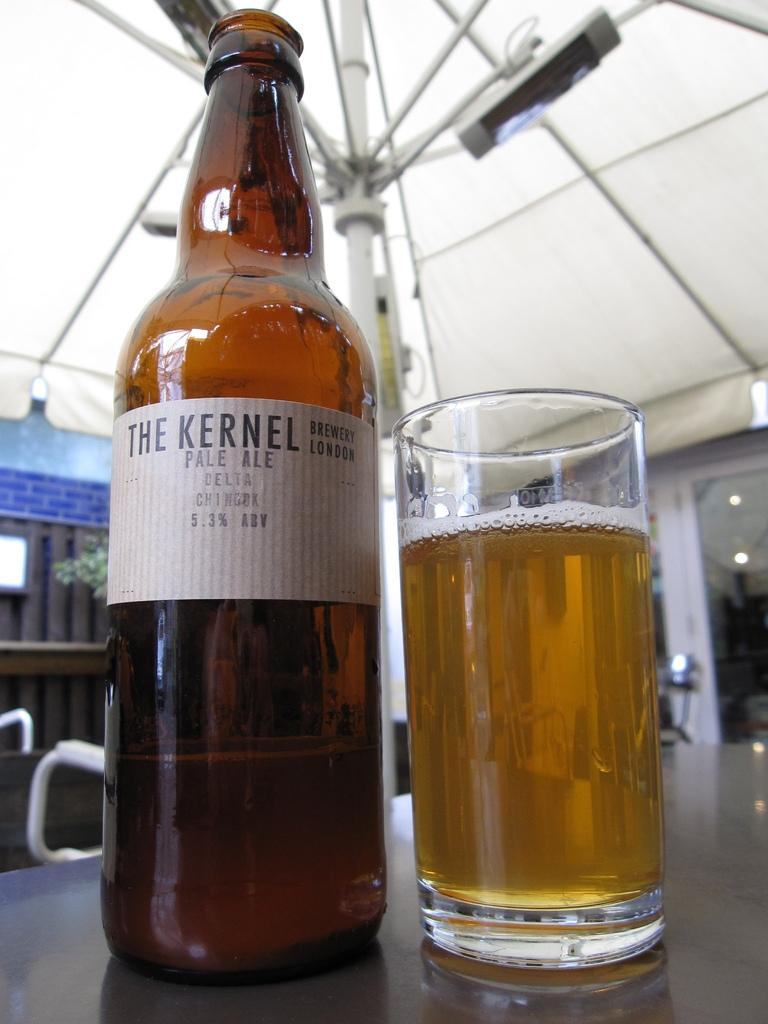<image>
Create a compact narrative representing the image presented. A bottle of The Kernel Pale Ale sits next to a glass of the beer on a table. 